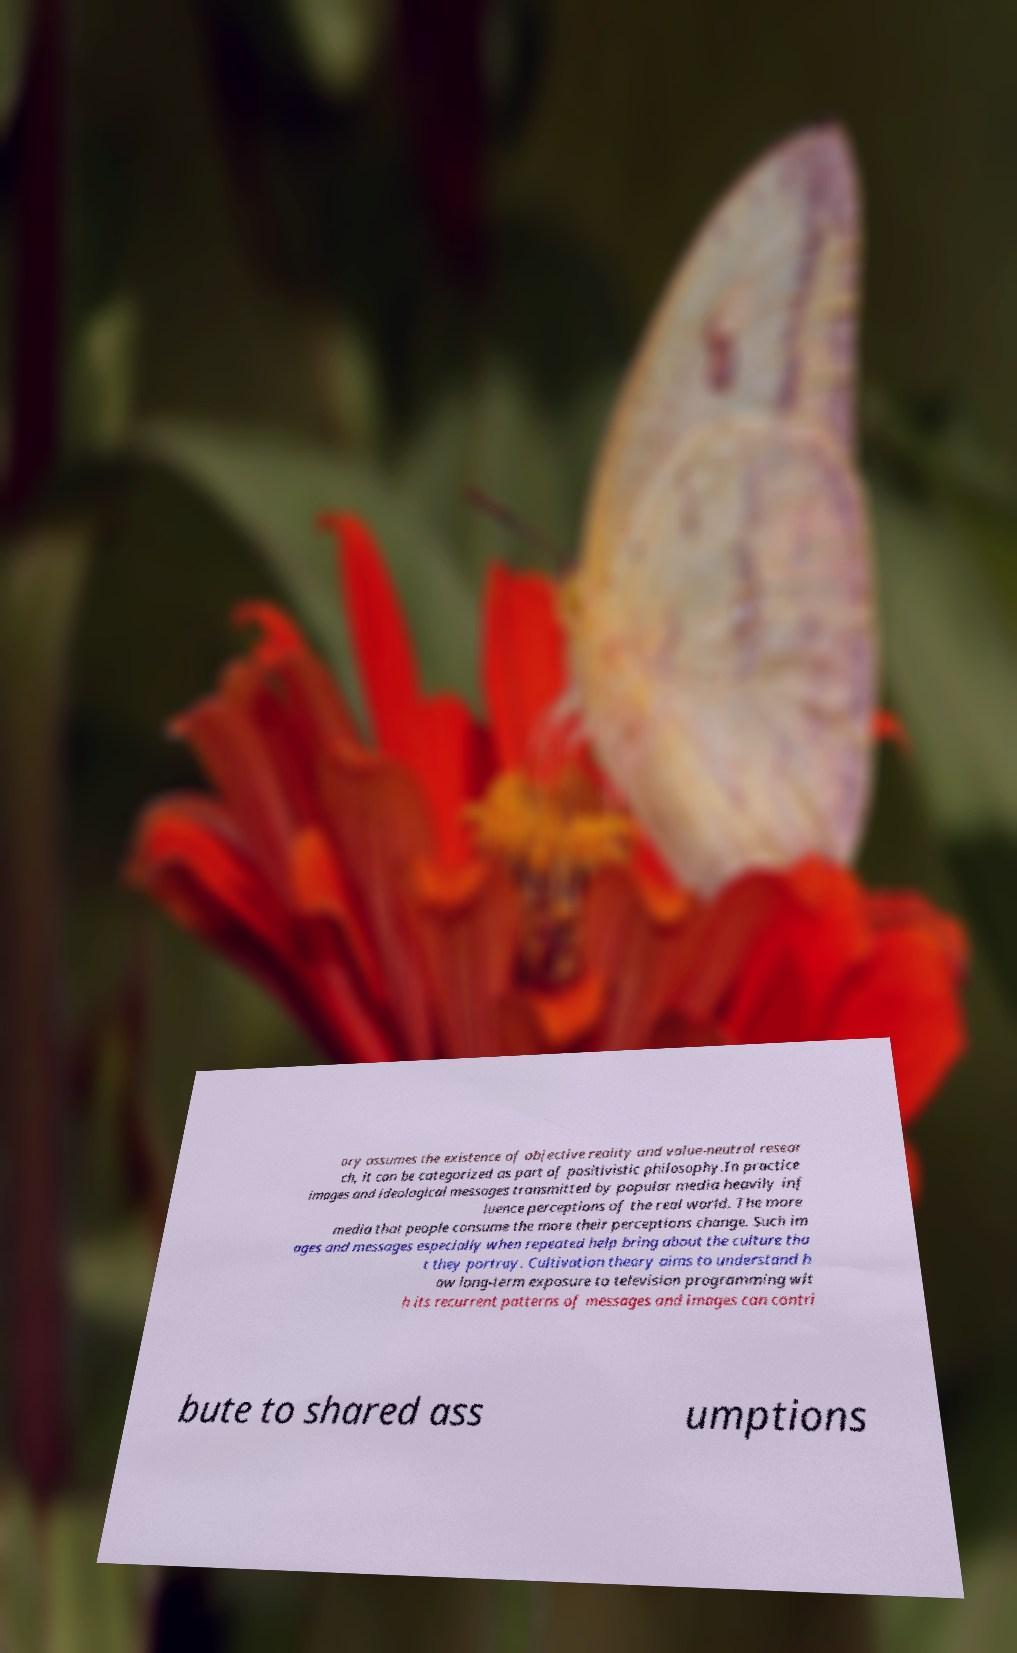For documentation purposes, I need the text within this image transcribed. Could you provide that? ory assumes the existence of objective reality and value-neutral resear ch, it can be categorized as part of positivistic philosophy.In practice images and ideological messages transmitted by popular media heavily inf luence perceptions of the real world. The more media that people consume the more their perceptions change. Such im ages and messages especially when repeated help bring about the culture tha t they portray. Cultivation theory aims to understand h ow long-term exposure to television programming wit h its recurrent patterns of messages and images can contri bute to shared ass umptions 